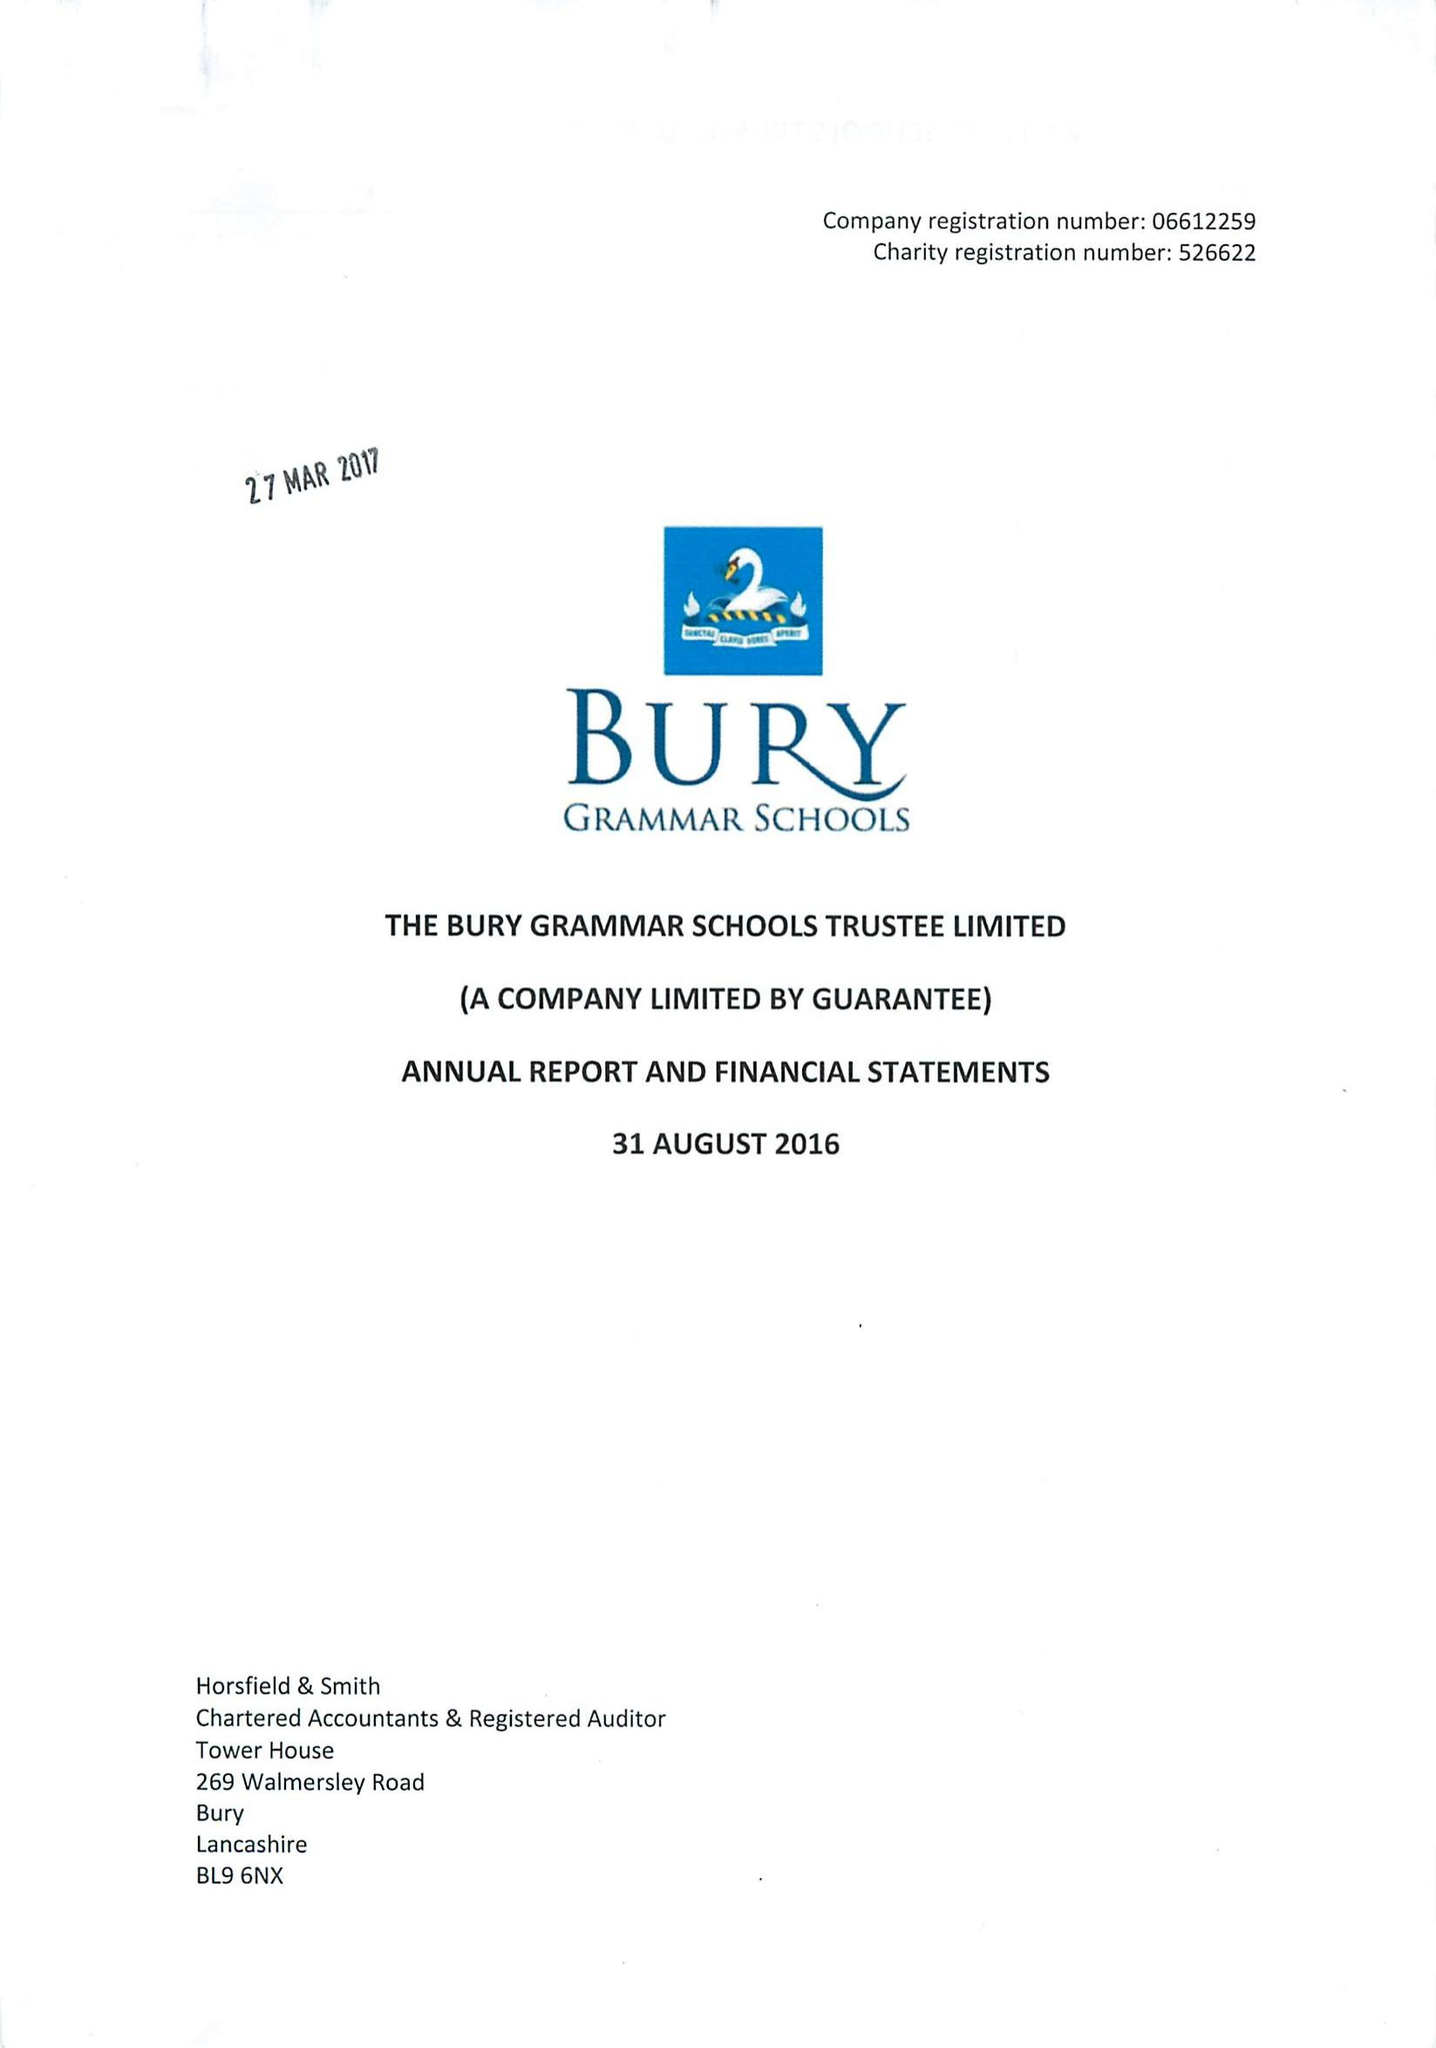What is the value for the address__street_line?
Answer the question using a single word or phrase. BRIDGE ROAD 